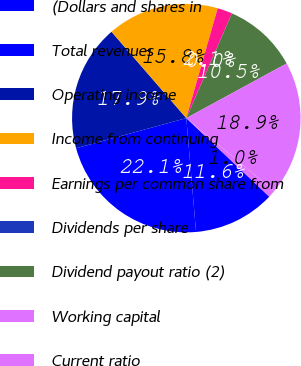Convert chart. <chart><loc_0><loc_0><loc_500><loc_500><pie_chart><fcel>(Dollars and shares in<fcel>Total revenues<fcel>Operating income<fcel>Income from continuing<fcel>Earnings per common share from<fcel>Dividends per share<fcel>Dividend payout ratio (2)<fcel>Working capital<fcel>Current ratio<nl><fcel>11.58%<fcel>22.11%<fcel>17.89%<fcel>15.79%<fcel>2.11%<fcel>0.0%<fcel>10.53%<fcel>18.95%<fcel>1.05%<nl></chart> 